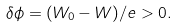Convert formula to latex. <formula><loc_0><loc_0><loc_500><loc_500>\delta \phi = ( W _ { 0 } - W ) / e > 0 .</formula> 